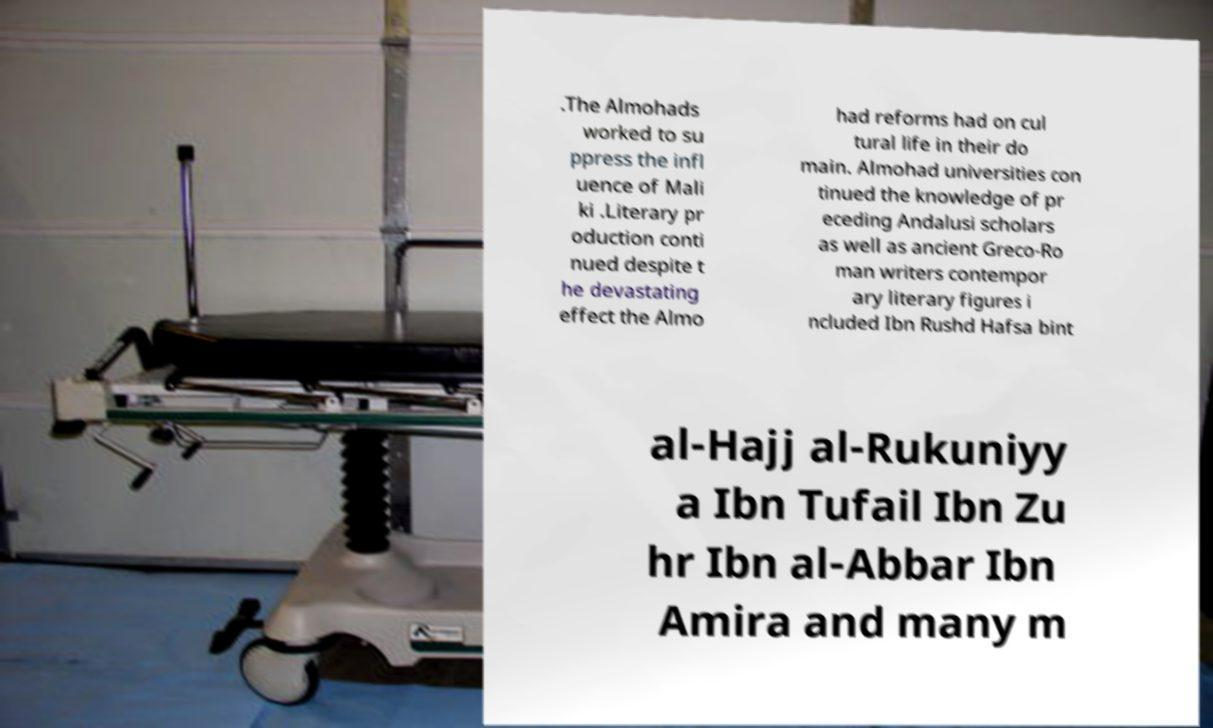What messages or text are displayed in this image? I need them in a readable, typed format. .The Almohads worked to su ppress the infl uence of Mali ki .Literary pr oduction conti nued despite t he devastating effect the Almo had reforms had on cul tural life in their do main. Almohad universities con tinued the knowledge of pr eceding Andalusi scholars as well as ancient Greco-Ro man writers contempor ary literary figures i ncluded Ibn Rushd Hafsa bint al-Hajj al-Rukuniyy a Ibn Tufail Ibn Zu hr Ibn al-Abbar Ibn Amira and many m 